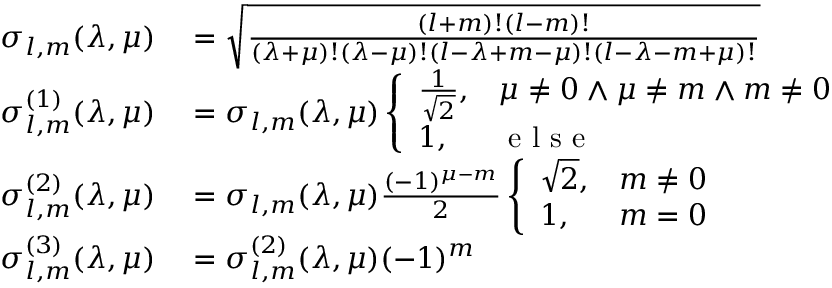Convert formula to latex. <formula><loc_0><loc_0><loc_500><loc_500>\begin{array} { r l } { \sigma _ { l , m } ( \lambda , \mu ) } & = \sqrt { \frac { ( l + m ) ! ( l - m ) ! } { ( \lambda + \mu ) ! ( \lambda - \mu ) ! ( l - \lambda + m - \mu ) ! ( l - \lambda - m + \mu ) ! } } } \\ { \sigma _ { l , m } ^ { ( 1 ) } ( \lambda , \mu ) } & = \sigma _ { l , m } ( \lambda , \mu ) \left \{ \begin{array} { l l } { \frac { 1 } { \sqrt { 2 } } , } & { \mu \neq 0 \land \mu \neq m \land m \neq 0 } \\ { 1 , } & { e l s e } \end{array} } \\ { \sigma _ { l , m } ^ { ( 2 ) } ( \lambda , \mu ) } & = \sigma _ { l , m } ( \lambda , \mu ) \frac { ( - 1 ) ^ { \mu - m } } { 2 } \left \{ \begin{array} { l l } { \sqrt { 2 } , } & { m \neq 0 } \\ { 1 , } & { m = 0 } \end{array} } \\ { \sigma _ { l , m } ^ { ( 3 ) } ( \lambda , \mu ) } & = \sigma _ { l , m } ^ { ( 2 ) } ( \lambda , \mu ) ( - 1 ) ^ { m } } \end{array}</formula> 